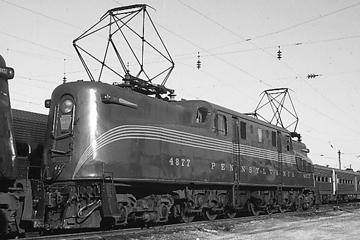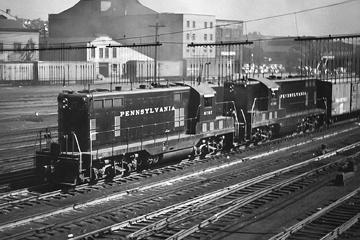The first image is the image on the left, the second image is the image on the right. For the images displayed, is the sentence "All trains are heading to the right." factually correct? Answer yes or no. No. The first image is the image on the left, the second image is the image on the right. For the images displayed, is the sentence "An image shows a train with a rounded front and a stripe that curves up from the bottom of the front to run along the side, and geometric 3D frames are above the train." factually correct? Answer yes or no. Yes. 